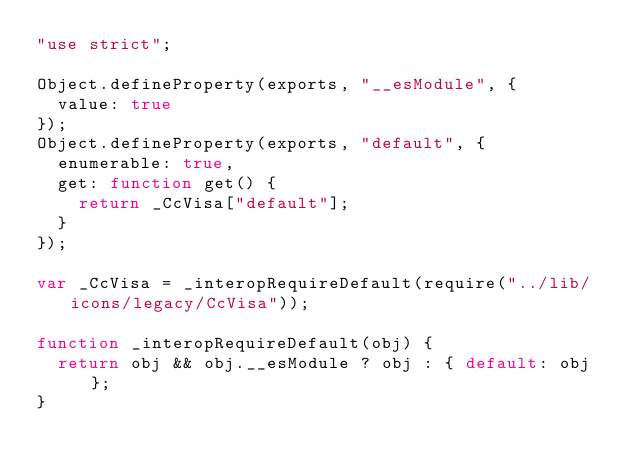<code> <loc_0><loc_0><loc_500><loc_500><_JavaScript_>"use strict";

Object.defineProperty(exports, "__esModule", {
  value: true
});
Object.defineProperty(exports, "default", {
  enumerable: true,
  get: function get() {
    return _CcVisa["default"];
  }
});

var _CcVisa = _interopRequireDefault(require("../lib/icons/legacy/CcVisa"));

function _interopRequireDefault(obj) {
  return obj && obj.__esModule ? obj : { default: obj };
}
</code> 